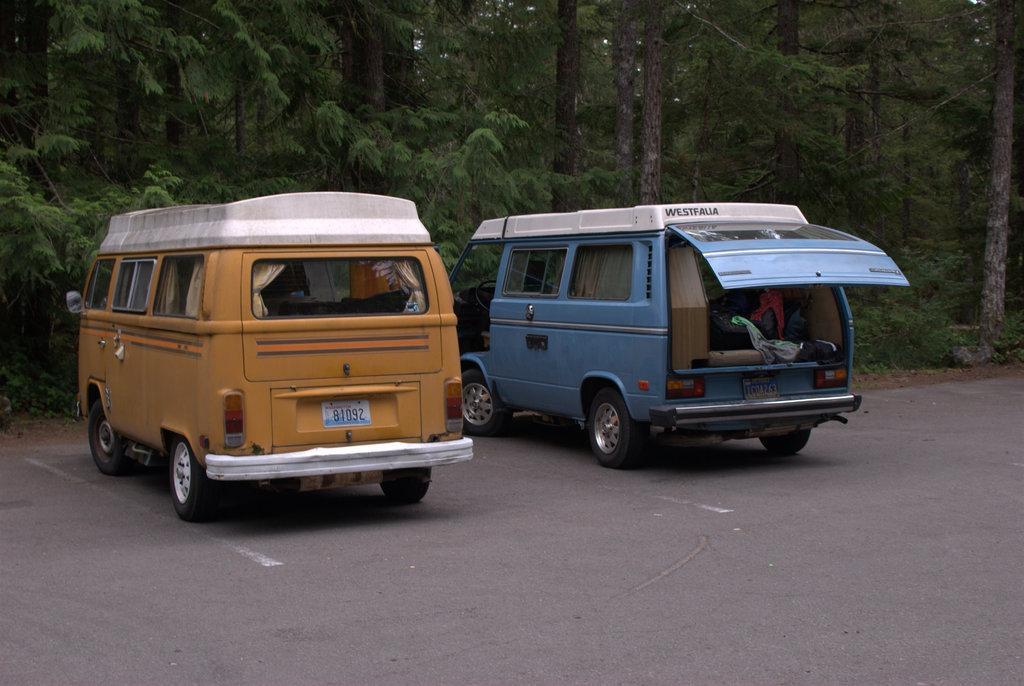Describe this image in one or two sentences. In the picture there are two vehicles parked in front of a forest on the road and the backdoor of one of the vehicle is open and inside that vehicle different items were kept. 